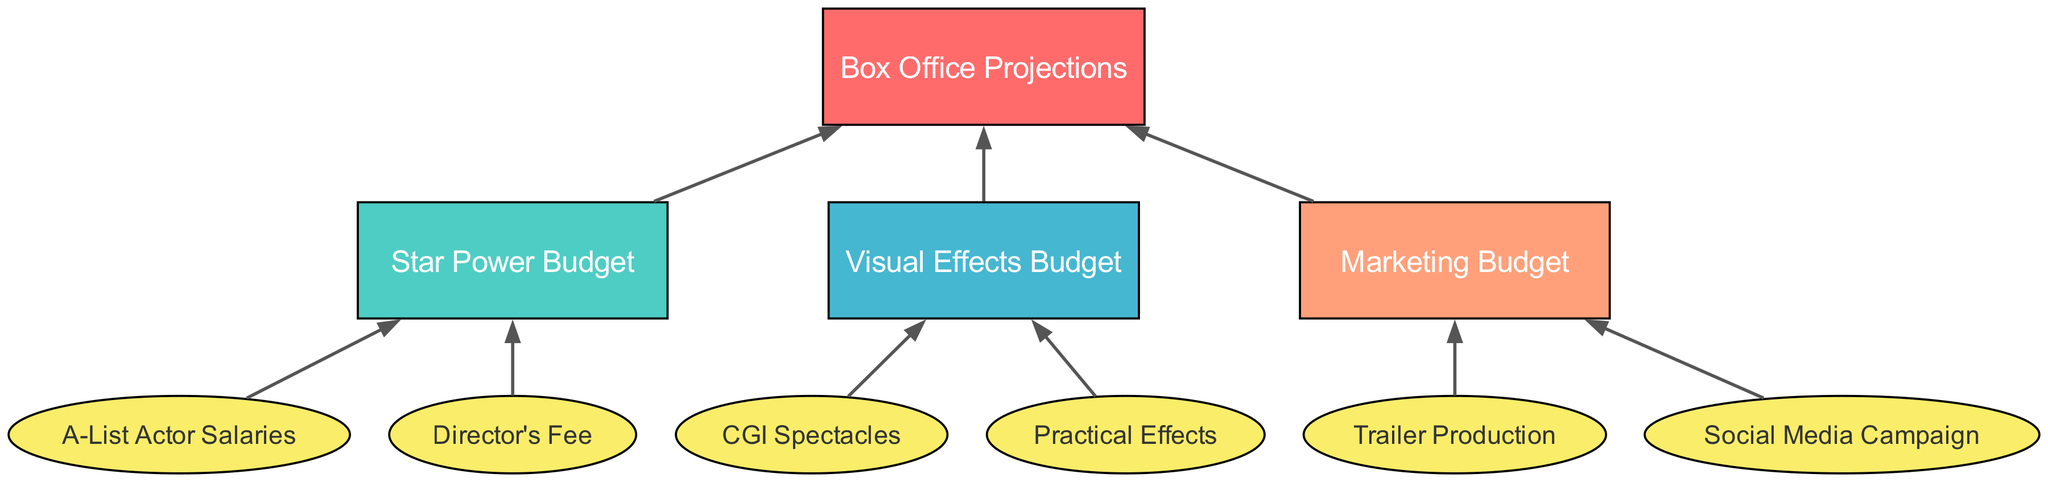What is the top node of the diagram? The top node in the flow chart is "Box Office Projections," which represents the main goal or directive of the budget allocation process. There are no nodes above this one.
Answer: Box Office Projections How many children does "Visual Effects Budget" have? The "Visual Effects Budget" node has two children nodes, namely "CGI Spectacles" and "Practical Effects." These represent the subcategories of the visual effects spending.
Answer: 2 What is the main focus of the "Marketing Budget" node? The "Marketing Budget" node encompasses both the "Trailer Production" and "Social Media Campaign" as its children nodes, indicating these are the crucial spending areas for marketing the film.
Answer: Trailer Production and Social Media Campaign Which node does the "Director's Fee" connect to? The "Director's Fee" is a child node of the "Star Power Budget," indicating that this expense is part of the allocation dedicated to securing talent for the film.
Answer: Star Power Budget What are the two types of visual effects detailed in the diagram? The "Visual Effects Budget" node has two children: "CGI Spectacles" and "Practical Effects," which categorize the different types of visual effects expenditures.
Answer: CGI Spectacles and Practical Effects What relationship exists between "Box Office Projections" and its child nodes? "Box Office Projections" is the primary goal that informs the allocation of budgets for "Star Power," "Visual Effects," and "Marketing." Each of these areas directly contributes to achieving projected box office success.
Answer: Budget allocation Which budget category does "A-List Actor Salaries" fall under? "A-List Actor Salaries" is categorized under the "Star Power Budget," which represents how much the production is willing to spend on high-profile actors to increase the film's marketability.
Answer: Star Power Budget What is unique about the "Star Power Budget" in relation to actor salaries? The "Star Power Budget" includes a specific allocation for "A-List Actor Salaries," directly indicating that a major aspect of this budget is aimed at attracting high-profile talent to the film.
Answer: A-List Actor Salaries How many total child nodes does "Box Office Projections" have? The "Box Office Projections" node has three child nodes: "Star Power Budget," "Visual Effects Budget," and "Marketing Budget," showing it as the starting point leading to multiple budget categories.
Answer: 3 